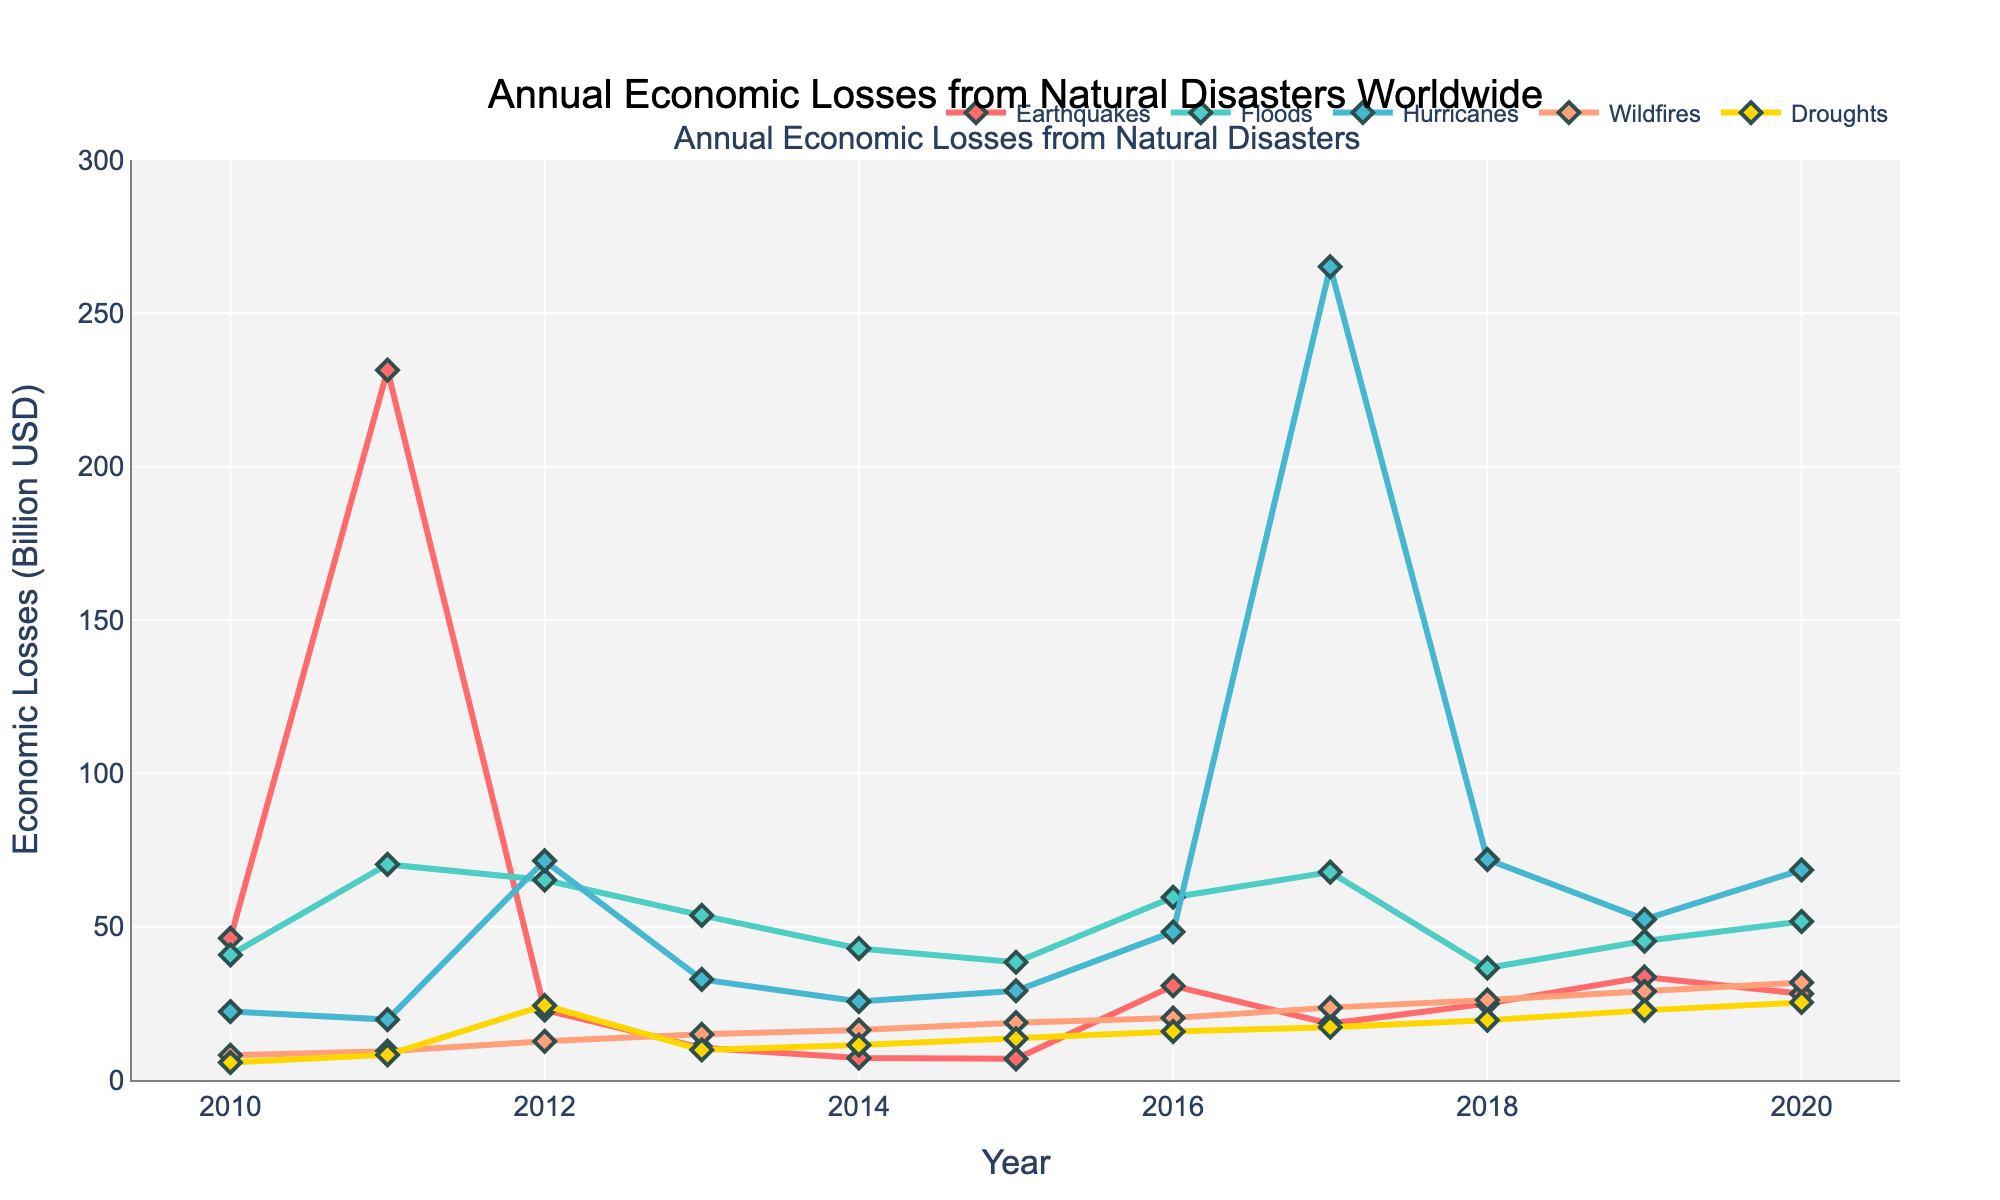What's the highest economic loss caused by earthquakes within the years shown? The highest economic loss for earthquakes is the peak value on the line for earthquakes. By looking at the chart, we see the peak is in 2011.
Answer: 231.5 billion USD Compare the economic losses due to hurricanes and floods in 2017. Which one was greater? To compare the economic losses in 2017, we need to check the values for hurricanes and floods for that year. Hurricanes shown in blue have a peak in 2017 reaching 265.2 billion USD, whereas floods in green are at 67.8 billion USD.
Answer: Hurricanes What is the sum of economic losses caused by wildfires and droughts in 2016? To find the sum, look at the values for wildfires and droughts in 2016. Wildfires are at 20.2 billion USD, and droughts are at 15.8 billion USD. The sum is 20.2 + 15.8 = 36 billion USD.
Answer: 36 billion USD How did the economic losses from earthquakes change from 2010 to 2011? To determine this, look at the values for earthquakes in 2010 and 2011. In 2010, losses were 46.2 billion USD, and in 2011, they were 231.5 billion USD. The change is 231.5 - 46.2 = 185.3 billion USD increase.
Answer: Increased by 185.3 billion USD Which type of disaster had the most consistent economic losses over the years? To identify the most consistent, look for the line that has the smallest variations. The line for droughts in yellow is relatively flat compared to other disaster types.
Answer: Droughts What's the average annual economic loss from hurricanes between 2010 and 2020? To find the average, add the economic losses from hurricanes from 2010 to 2020, and divide by the number of years. The sum is 22.3 + 19.7 + 71.5 + 32.8 + 25.6 + 29.1 + 48.3 + 265.2 + 71.9 + 52.4 + 68.5 = 707.3. To find the average, 707.3 / 11 = 64.3 billion USD.
Answer: 64.3 billion USD In which year did economic losses due to floods peak? The peak value for floods, represented by the height of the green line, is in 2011 with 70.3 billion USD.
Answer: 2011 During which year were the combined economic losses from wildfires and floods the highest? To find the combined highest, sum the values for each year and determine the highest total. In 2020, it was 31.8 + 51.7 = 83.5 billion USD. None exceeds that.
Answer: 2020 What is the difference in economic losses due to wildfires between 2013 and 2014? Check the values for wildfires in 2013 and 2014. In 2013 it was 14.9 billion USD, and in 2014, it was 16.3 billion USD. The difference is 16.3 - 14.9 = 1.4 billion USD.
Answer: 1.4 billion USD Between 2018 and 2019, which disaster type saw the biggest increase in economic losses? Compare the values between 2018 and 2019. Earthquakes increased from 24.9 to 33.6 billion USD (8.7), floods from 36.5 to 45.3 (8.8), hurricanes from 71.9 to 52.4 (-19.5), wildfires from 26.1 to 28.9 (2.8), and droughts from 19.5 to 22.7 (3.2). The biggest increase is in floods with 8.8 billion USD.
Answer: Floods 